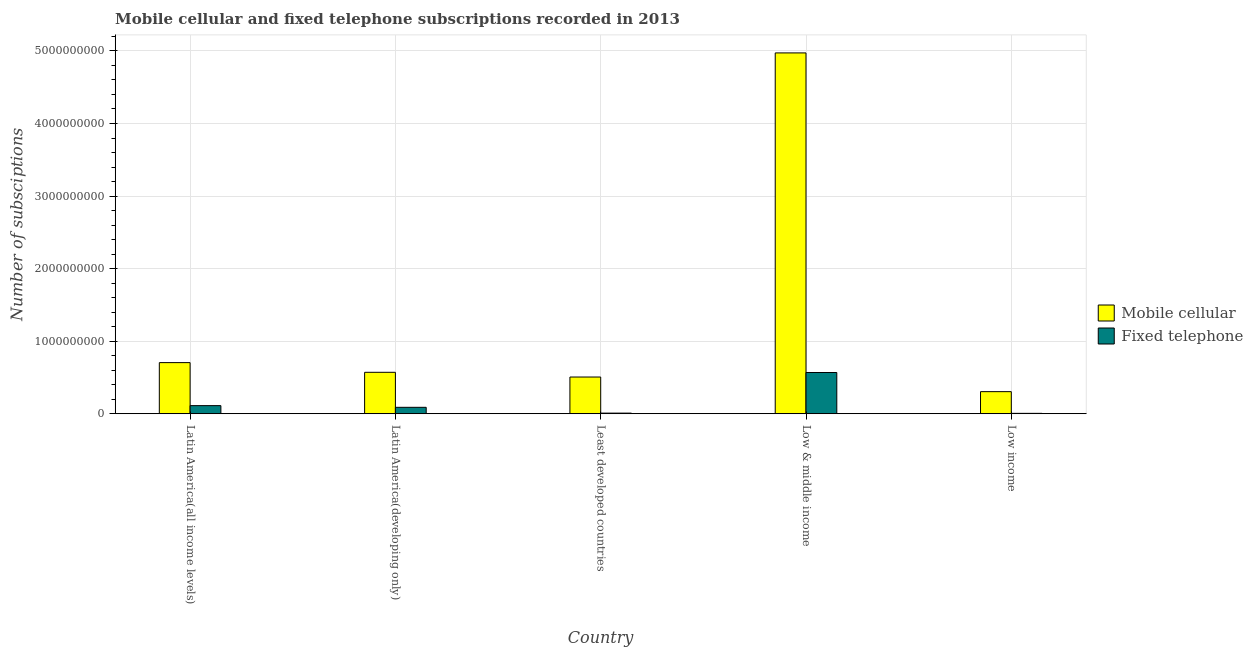Are the number of bars per tick equal to the number of legend labels?
Your answer should be compact. Yes. How many bars are there on the 3rd tick from the left?
Ensure brevity in your answer.  2. How many bars are there on the 1st tick from the right?
Make the answer very short. 2. What is the label of the 4th group of bars from the left?
Provide a short and direct response. Low & middle income. In how many cases, is the number of bars for a given country not equal to the number of legend labels?
Provide a short and direct response. 0. What is the number of fixed telephone subscriptions in Latin America(all income levels)?
Keep it short and to the point. 1.12e+08. Across all countries, what is the maximum number of mobile cellular subscriptions?
Offer a terse response. 4.97e+09. Across all countries, what is the minimum number of mobile cellular subscriptions?
Make the answer very short. 3.05e+08. In which country was the number of fixed telephone subscriptions maximum?
Provide a succinct answer. Low & middle income. In which country was the number of fixed telephone subscriptions minimum?
Give a very brief answer. Low income. What is the total number of mobile cellular subscriptions in the graph?
Your response must be concise. 7.06e+09. What is the difference between the number of fixed telephone subscriptions in Latin America(developing only) and that in Low income?
Your answer should be very brief. 8.32e+07. What is the difference between the number of fixed telephone subscriptions in Low income and the number of mobile cellular subscriptions in Low & middle income?
Make the answer very short. -4.97e+09. What is the average number of fixed telephone subscriptions per country?
Ensure brevity in your answer.  1.56e+08. What is the difference between the number of mobile cellular subscriptions and number of fixed telephone subscriptions in Low income?
Your answer should be compact. 2.99e+08. What is the ratio of the number of fixed telephone subscriptions in Latin America(developing only) to that in Least developed countries?
Keep it short and to the point. 10.26. Is the number of fixed telephone subscriptions in Latin America(developing only) less than that in Low & middle income?
Offer a terse response. Yes. Is the difference between the number of mobile cellular subscriptions in Latin America(all income levels) and Least developed countries greater than the difference between the number of fixed telephone subscriptions in Latin America(all income levels) and Least developed countries?
Keep it short and to the point. Yes. What is the difference between the highest and the second highest number of fixed telephone subscriptions?
Provide a succinct answer. 4.57e+08. What is the difference between the highest and the lowest number of fixed telephone subscriptions?
Offer a very short reply. 5.63e+08. Is the sum of the number of fixed telephone subscriptions in Low & middle income and Low income greater than the maximum number of mobile cellular subscriptions across all countries?
Your answer should be compact. No. What does the 2nd bar from the left in Latin America(developing only) represents?
Provide a succinct answer. Fixed telephone. What does the 1st bar from the right in Low income represents?
Your answer should be compact. Fixed telephone. Are all the bars in the graph horizontal?
Ensure brevity in your answer.  No. Does the graph contain any zero values?
Provide a succinct answer. No. How many legend labels are there?
Make the answer very short. 2. What is the title of the graph?
Ensure brevity in your answer.  Mobile cellular and fixed telephone subscriptions recorded in 2013. Does "Female population" appear as one of the legend labels in the graph?
Provide a succinct answer. No. What is the label or title of the Y-axis?
Keep it short and to the point. Number of subsciptions. What is the Number of subsciptions of Mobile cellular in Latin America(all income levels)?
Your answer should be very brief. 7.05e+08. What is the Number of subsciptions of Fixed telephone in Latin America(all income levels)?
Your response must be concise. 1.12e+08. What is the Number of subsciptions of Mobile cellular in Latin America(developing only)?
Offer a terse response. 5.71e+08. What is the Number of subsciptions of Fixed telephone in Latin America(developing only)?
Provide a short and direct response. 8.85e+07. What is the Number of subsciptions in Mobile cellular in Least developed countries?
Provide a succinct answer. 5.06e+08. What is the Number of subsciptions of Fixed telephone in Least developed countries?
Offer a very short reply. 8.62e+06. What is the Number of subsciptions of Mobile cellular in Low & middle income?
Your answer should be very brief. 4.97e+09. What is the Number of subsciptions of Fixed telephone in Low & middle income?
Make the answer very short. 5.68e+08. What is the Number of subsciptions in Mobile cellular in Low income?
Give a very brief answer. 3.05e+08. What is the Number of subsciptions in Fixed telephone in Low income?
Your answer should be compact. 5.36e+06. Across all countries, what is the maximum Number of subsciptions in Mobile cellular?
Offer a very short reply. 4.97e+09. Across all countries, what is the maximum Number of subsciptions of Fixed telephone?
Provide a succinct answer. 5.68e+08. Across all countries, what is the minimum Number of subsciptions of Mobile cellular?
Your answer should be very brief. 3.05e+08. Across all countries, what is the minimum Number of subsciptions in Fixed telephone?
Keep it short and to the point. 5.36e+06. What is the total Number of subsciptions in Mobile cellular in the graph?
Your response must be concise. 7.06e+09. What is the total Number of subsciptions of Fixed telephone in the graph?
Your answer should be compact. 7.82e+08. What is the difference between the Number of subsciptions in Mobile cellular in Latin America(all income levels) and that in Latin America(developing only)?
Offer a terse response. 1.33e+08. What is the difference between the Number of subsciptions in Fixed telephone in Latin America(all income levels) and that in Latin America(developing only)?
Offer a terse response. 2.32e+07. What is the difference between the Number of subsciptions of Mobile cellular in Latin America(all income levels) and that in Least developed countries?
Provide a succinct answer. 1.98e+08. What is the difference between the Number of subsciptions of Fixed telephone in Latin America(all income levels) and that in Least developed countries?
Your answer should be very brief. 1.03e+08. What is the difference between the Number of subsciptions in Mobile cellular in Latin America(all income levels) and that in Low & middle income?
Your response must be concise. -4.27e+09. What is the difference between the Number of subsciptions of Fixed telephone in Latin America(all income levels) and that in Low & middle income?
Provide a succinct answer. -4.57e+08. What is the difference between the Number of subsciptions in Mobile cellular in Latin America(all income levels) and that in Low income?
Offer a very short reply. 4.00e+08. What is the difference between the Number of subsciptions of Fixed telephone in Latin America(all income levels) and that in Low income?
Give a very brief answer. 1.06e+08. What is the difference between the Number of subsciptions in Mobile cellular in Latin America(developing only) and that in Least developed countries?
Offer a very short reply. 6.50e+07. What is the difference between the Number of subsciptions in Fixed telephone in Latin America(developing only) and that in Least developed countries?
Offer a terse response. 7.99e+07. What is the difference between the Number of subsciptions in Mobile cellular in Latin America(developing only) and that in Low & middle income?
Ensure brevity in your answer.  -4.40e+09. What is the difference between the Number of subsciptions of Fixed telephone in Latin America(developing only) and that in Low & middle income?
Your answer should be compact. -4.80e+08. What is the difference between the Number of subsciptions in Mobile cellular in Latin America(developing only) and that in Low income?
Offer a terse response. 2.67e+08. What is the difference between the Number of subsciptions of Fixed telephone in Latin America(developing only) and that in Low income?
Your answer should be compact. 8.32e+07. What is the difference between the Number of subsciptions in Mobile cellular in Least developed countries and that in Low & middle income?
Keep it short and to the point. -4.47e+09. What is the difference between the Number of subsciptions in Fixed telephone in Least developed countries and that in Low & middle income?
Give a very brief answer. -5.60e+08. What is the difference between the Number of subsciptions in Mobile cellular in Least developed countries and that in Low income?
Provide a short and direct response. 2.02e+08. What is the difference between the Number of subsciptions in Fixed telephone in Least developed countries and that in Low income?
Keep it short and to the point. 3.27e+06. What is the difference between the Number of subsciptions of Mobile cellular in Low & middle income and that in Low income?
Provide a short and direct response. 4.67e+09. What is the difference between the Number of subsciptions of Fixed telephone in Low & middle income and that in Low income?
Make the answer very short. 5.63e+08. What is the difference between the Number of subsciptions of Mobile cellular in Latin America(all income levels) and the Number of subsciptions of Fixed telephone in Latin America(developing only)?
Keep it short and to the point. 6.16e+08. What is the difference between the Number of subsciptions in Mobile cellular in Latin America(all income levels) and the Number of subsciptions in Fixed telephone in Least developed countries?
Make the answer very short. 6.96e+08. What is the difference between the Number of subsciptions in Mobile cellular in Latin America(all income levels) and the Number of subsciptions in Fixed telephone in Low & middle income?
Provide a short and direct response. 1.36e+08. What is the difference between the Number of subsciptions in Mobile cellular in Latin America(all income levels) and the Number of subsciptions in Fixed telephone in Low income?
Offer a terse response. 6.99e+08. What is the difference between the Number of subsciptions of Mobile cellular in Latin America(developing only) and the Number of subsciptions of Fixed telephone in Least developed countries?
Provide a succinct answer. 5.62e+08. What is the difference between the Number of subsciptions in Mobile cellular in Latin America(developing only) and the Number of subsciptions in Fixed telephone in Low & middle income?
Your answer should be very brief. 2.90e+06. What is the difference between the Number of subsciptions of Mobile cellular in Latin America(developing only) and the Number of subsciptions of Fixed telephone in Low income?
Your answer should be very brief. 5.66e+08. What is the difference between the Number of subsciptions in Mobile cellular in Least developed countries and the Number of subsciptions in Fixed telephone in Low & middle income?
Make the answer very short. -6.21e+07. What is the difference between the Number of subsciptions of Mobile cellular in Least developed countries and the Number of subsciptions of Fixed telephone in Low income?
Give a very brief answer. 5.01e+08. What is the difference between the Number of subsciptions of Mobile cellular in Low & middle income and the Number of subsciptions of Fixed telephone in Low income?
Make the answer very short. 4.97e+09. What is the average Number of subsciptions of Mobile cellular per country?
Your answer should be compact. 1.41e+09. What is the average Number of subsciptions of Fixed telephone per country?
Offer a very short reply. 1.56e+08. What is the difference between the Number of subsciptions of Mobile cellular and Number of subsciptions of Fixed telephone in Latin America(all income levels)?
Your response must be concise. 5.93e+08. What is the difference between the Number of subsciptions in Mobile cellular and Number of subsciptions in Fixed telephone in Latin America(developing only)?
Provide a short and direct response. 4.83e+08. What is the difference between the Number of subsciptions in Mobile cellular and Number of subsciptions in Fixed telephone in Least developed countries?
Offer a very short reply. 4.97e+08. What is the difference between the Number of subsciptions of Mobile cellular and Number of subsciptions of Fixed telephone in Low & middle income?
Offer a terse response. 4.40e+09. What is the difference between the Number of subsciptions of Mobile cellular and Number of subsciptions of Fixed telephone in Low income?
Make the answer very short. 2.99e+08. What is the ratio of the Number of subsciptions of Mobile cellular in Latin America(all income levels) to that in Latin America(developing only)?
Your answer should be very brief. 1.23. What is the ratio of the Number of subsciptions of Fixed telephone in Latin America(all income levels) to that in Latin America(developing only)?
Make the answer very short. 1.26. What is the ratio of the Number of subsciptions of Mobile cellular in Latin America(all income levels) to that in Least developed countries?
Make the answer very short. 1.39. What is the ratio of the Number of subsciptions in Fixed telephone in Latin America(all income levels) to that in Least developed countries?
Ensure brevity in your answer.  12.95. What is the ratio of the Number of subsciptions of Mobile cellular in Latin America(all income levels) to that in Low & middle income?
Give a very brief answer. 0.14. What is the ratio of the Number of subsciptions in Fixed telephone in Latin America(all income levels) to that in Low & middle income?
Provide a short and direct response. 0.2. What is the ratio of the Number of subsciptions in Mobile cellular in Latin America(all income levels) to that in Low income?
Keep it short and to the point. 2.31. What is the ratio of the Number of subsciptions of Fixed telephone in Latin America(all income levels) to that in Low income?
Your answer should be very brief. 20.85. What is the ratio of the Number of subsciptions of Mobile cellular in Latin America(developing only) to that in Least developed countries?
Make the answer very short. 1.13. What is the ratio of the Number of subsciptions in Fixed telephone in Latin America(developing only) to that in Least developed countries?
Provide a succinct answer. 10.26. What is the ratio of the Number of subsciptions in Mobile cellular in Latin America(developing only) to that in Low & middle income?
Make the answer very short. 0.11. What is the ratio of the Number of subsciptions in Fixed telephone in Latin America(developing only) to that in Low & middle income?
Your answer should be very brief. 0.16. What is the ratio of the Number of subsciptions of Mobile cellular in Latin America(developing only) to that in Low income?
Make the answer very short. 1.88. What is the ratio of the Number of subsciptions in Fixed telephone in Latin America(developing only) to that in Low income?
Provide a succinct answer. 16.52. What is the ratio of the Number of subsciptions of Mobile cellular in Least developed countries to that in Low & middle income?
Your answer should be compact. 0.1. What is the ratio of the Number of subsciptions of Fixed telephone in Least developed countries to that in Low & middle income?
Give a very brief answer. 0.02. What is the ratio of the Number of subsciptions of Mobile cellular in Least developed countries to that in Low income?
Your answer should be compact. 1.66. What is the ratio of the Number of subsciptions of Fixed telephone in Least developed countries to that in Low income?
Your response must be concise. 1.61. What is the ratio of the Number of subsciptions in Mobile cellular in Low & middle income to that in Low income?
Offer a very short reply. 16.33. What is the ratio of the Number of subsciptions of Fixed telephone in Low & middle income to that in Low income?
Keep it short and to the point. 106.07. What is the difference between the highest and the second highest Number of subsciptions in Mobile cellular?
Give a very brief answer. 4.27e+09. What is the difference between the highest and the second highest Number of subsciptions of Fixed telephone?
Make the answer very short. 4.57e+08. What is the difference between the highest and the lowest Number of subsciptions in Mobile cellular?
Offer a terse response. 4.67e+09. What is the difference between the highest and the lowest Number of subsciptions in Fixed telephone?
Give a very brief answer. 5.63e+08. 